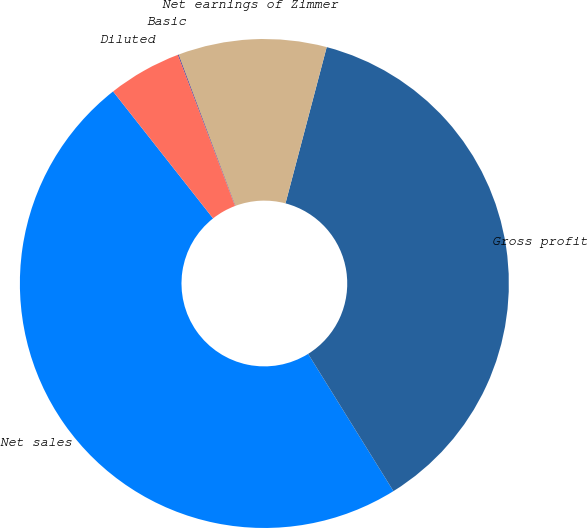Convert chart. <chart><loc_0><loc_0><loc_500><loc_500><pie_chart><fcel>Net sales<fcel>Gross profit<fcel>Net earnings of Zimmer<fcel>Basic<fcel>Diluted<nl><fcel>48.23%<fcel>37.04%<fcel>9.82%<fcel>0.04%<fcel>4.86%<nl></chart> 